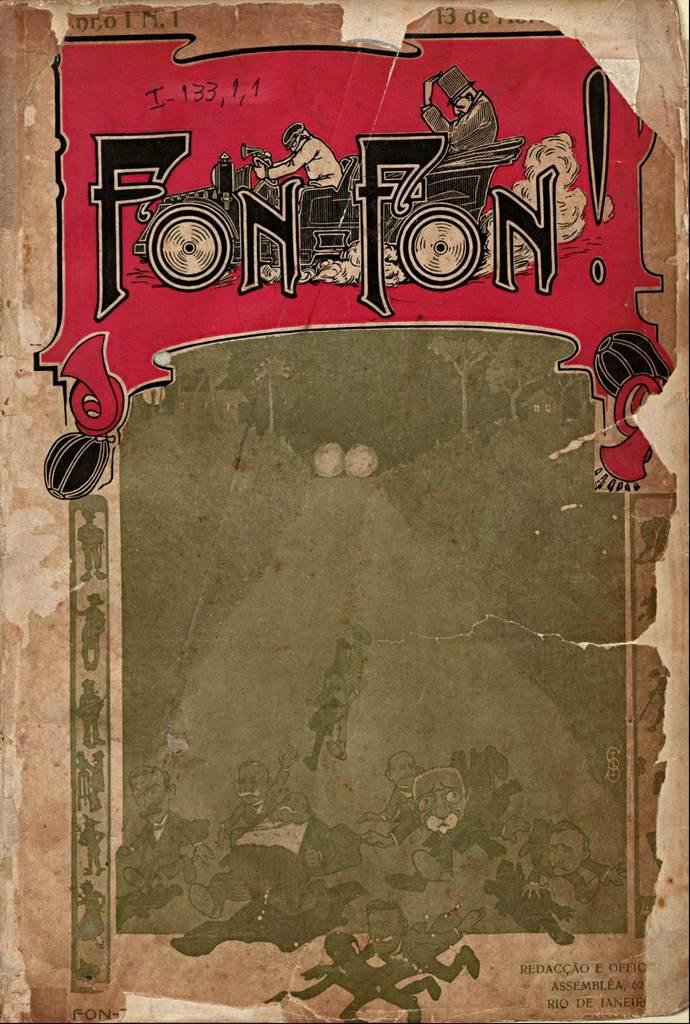What's the name of this book?
Make the answer very short. Fon fon. What is the title of the book?
Your response must be concise. Fon fon. 